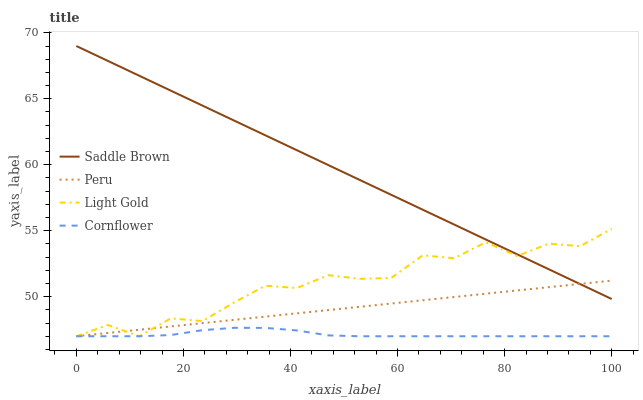Does Cornflower have the minimum area under the curve?
Answer yes or no. Yes. Does Saddle Brown have the maximum area under the curve?
Answer yes or no. Yes. Does Light Gold have the minimum area under the curve?
Answer yes or no. No. Does Light Gold have the maximum area under the curve?
Answer yes or no. No. Is Peru the smoothest?
Answer yes or no. Yes. Is Light Gold the roughest?
Answer yes or no. Yes. Is Saddle Brown the smoothest?
Answer yes or no. No. Is Saddle Brown the roughest?
Answer yes or no. No. Does Cornflower have the lowest value?
Answer yes or no. Yes. Does Saddle Brown have the lowest value?
Answer yes or no. No. Does Saddle Brown have the highest value?
Answer yes or no. Yes. Does Light Gold have the highest value?
Answer yes or no. No. Is Cornflower less than Saddle Brown?
Answer yes or no. Yes. Is Saddle Brown greater than Cornflower?
Answer yes or no. Yes. Does Cornflower intersect Light Gold?
Answer yes or no. Yes. Is Cornflower less than Light Gold?
Answer yes or no. No. Is Cornflower greater than Light Gold?
Answer yes or no. No. Does Cornflower intersect Saddle Brown?
Answer yes or no. No. 